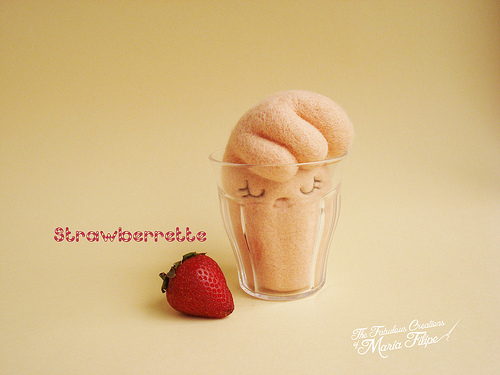<image>
Can you confirm if the glass is in front of the strawberry? No. The glass is not in front of the strawberry. The spatial positioning shows a different relationship between these objects. 